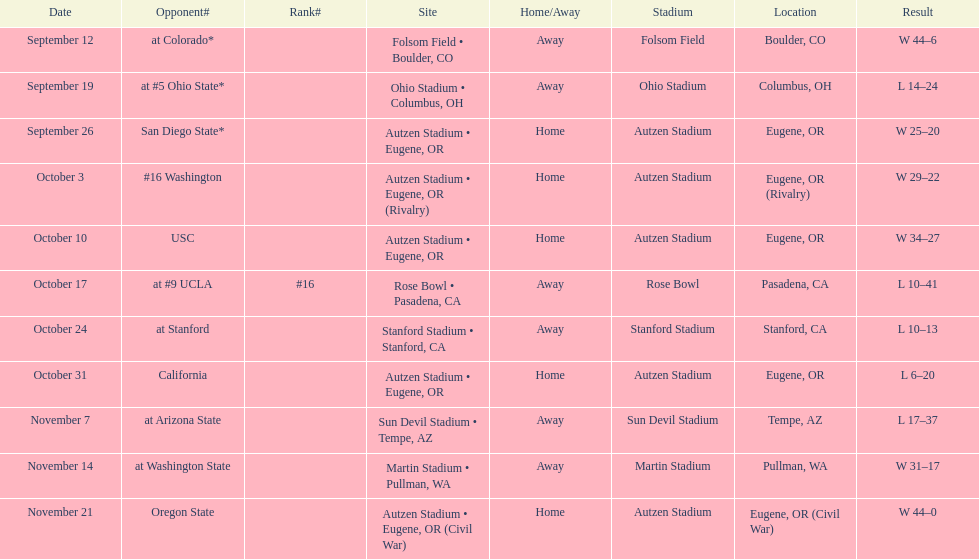Which bowl game did the university of oregon ducks football team play in during the 1987 season? Rose Bowl. 